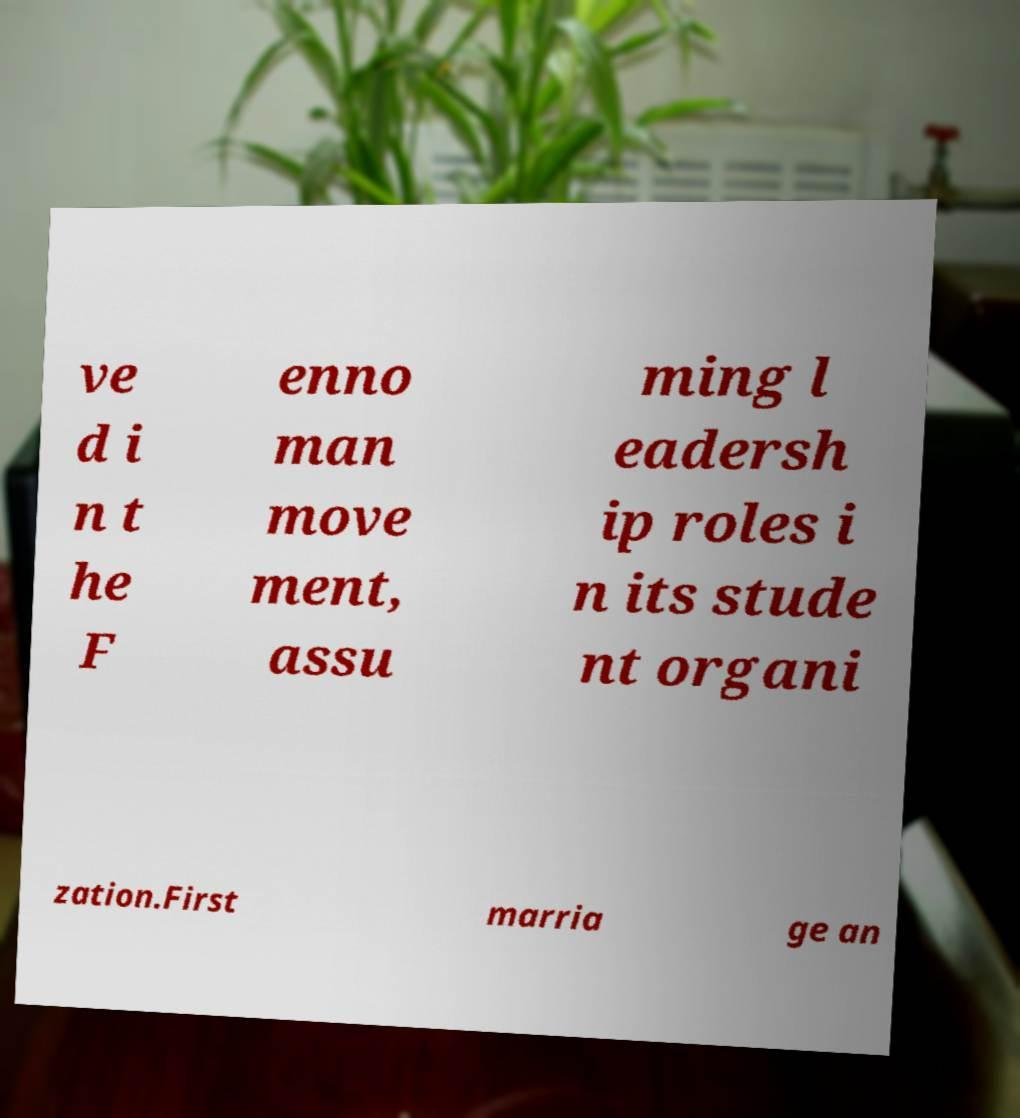Can you read and provide the text displayed in the image?This photo seems to have some interesting text. Can you extract and type it out for me? ve d i n t he F enno man move ment, assu ming l eadersh ip roles i n its stude nt organi zation.First marria ge an 